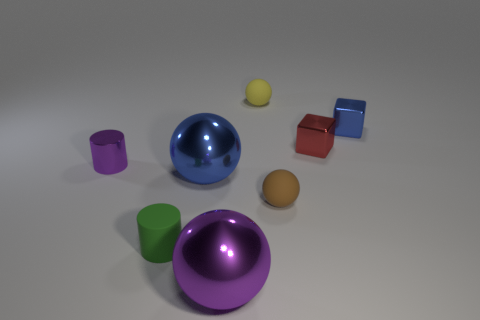How many green cylinders are there?
Your answer should be compact. 1. There is a red cube; how many large blue things are in front of it?
Make the answer very short. 1. Do the green thing and the tiny blue thing have the same material?
Your answer should be very brief. No. How many rubber objects are both behind the green matte cylinder and in front of the small metal cylinder?
Ensure brevity in your answer.  1. What number of other things are there of the same color as the matte cylinder?
Your answer should be very brief. 0. What number of brown things are big metal objects or tiny things?
Make the answer very short. 1. What is the size of the yellow thing?
Your answer should be compact. Small. How many metal objects are either tiny red blocks or big purple things?
Make the answer very short. 2. Is the number of big green metallic cylinders less than the number of blue cubes?
Your answer should be very brief. Yes. What number of other things are the same material as the tiny green cylinder?
Offer a very short reply. 2. 